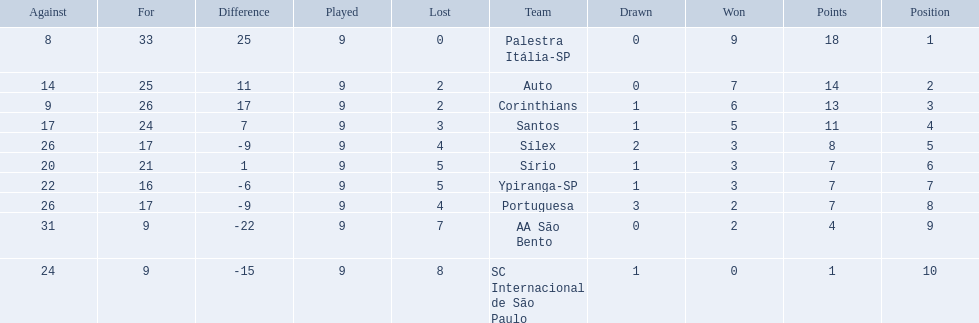Brazilian football in 1926 what teams had no draws? Palestra Itália-SP, Auto, AA São Bento. Of the teams with no draws name the 2 who lost the lease. Palestra Itália-SP, Auto. What team of the 2 who lost the least and had no draws had the highest difference? Palestra Itália-SP. 